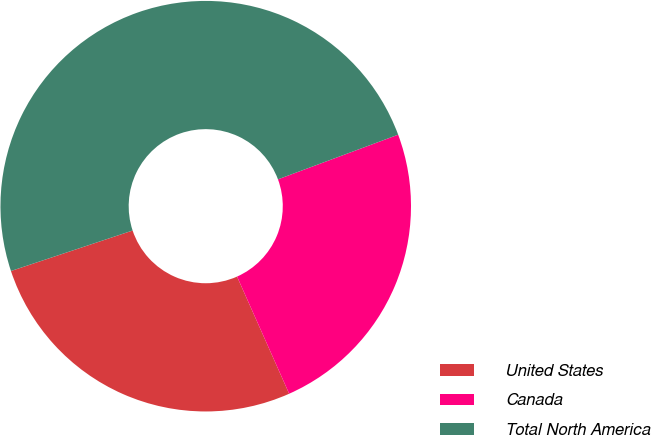Convert chart to OTSL. <chart><loc_0><loc_0><loc_500><loc_500><pie_chart><fcel>United States<fcel>Canada<fcel>Total North America<nl><fcel>26.55%<fcel>24.0%<fcel>49.45%<nl></chart> 